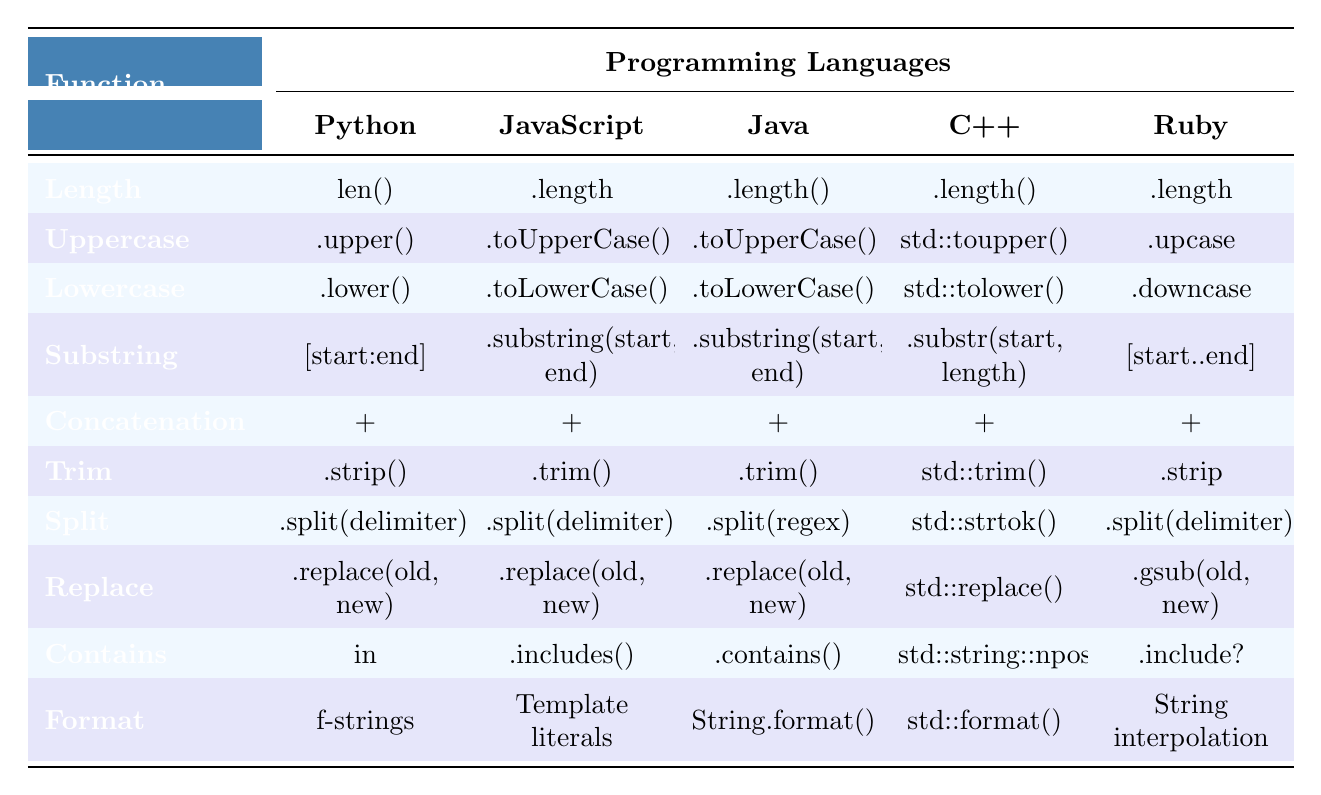What is the string function used to get the length of a string in Python? In the table, the function under the "Length" row for Python is specified as "len()".
Answer: len() Which programming languages have the same function for converting a string to uppercase? The table shows that both JavaScript and Java use ".toUpperCase()" for the Uppercase function, while Python uses ".upper()", C++ uses "std::toupper()", and Ruby uses ".upcase".
Answer: JavaScript and Java Is there any programming language that uses a different method for splitting strings compared to the others? Yes, in the table, C++ uses "std::strtok()" to split strings, whereas the other languages use ".split()".
Answer: Yes What is the string manipulation function used for trimming spaces in Ruby? For trimming spaces, Ruby uses ".strip" as per the Trim row in the table.
Answer: .strip Which string function is common across all languages for concatenation? The table indicates that all programming languages use the "+" operator for concatenation.
Answer: Yes What are the functions used to check if a string contains a substring in Python and Ruby? Python uses "in" and Ruby uses ".include?" for checking if a string contains a substring.
Answer: in, .include? How many different methods are used to format strings among the listed languages? By examining the table, we see that Python, JavaScript, Java, C++, and Ruby all utilize different methods for string formatting: f-strings, Template literals, String.format(), std::format(), and String interpolation, respectively. Therefore, there are 5 distinct methods.
Answer: 5 Which language has a unique function for replacing parts of a string compared to the others? The table shows that Ruby uses ".gsub(old, new)" for the Replace function, whereas the other languages use similar syntax with ".replace()".
Answer: Ruby If we consider the use of lowercase conversion, which languages utilize the same function? The table indicates that Python, JavaScript, and Java all use ".toLowerCase()" for the Lowercase function, while C++ uses "std::tolower()" and Ruby uses ".downcase".
Answer: Python, JavaScript, Java What would be the function to create a substring from a string in Java? According to the Substring row in the table, in Java the function used for creating a substring is ".substring(start, end)".
Answer: .substring(start, end) 